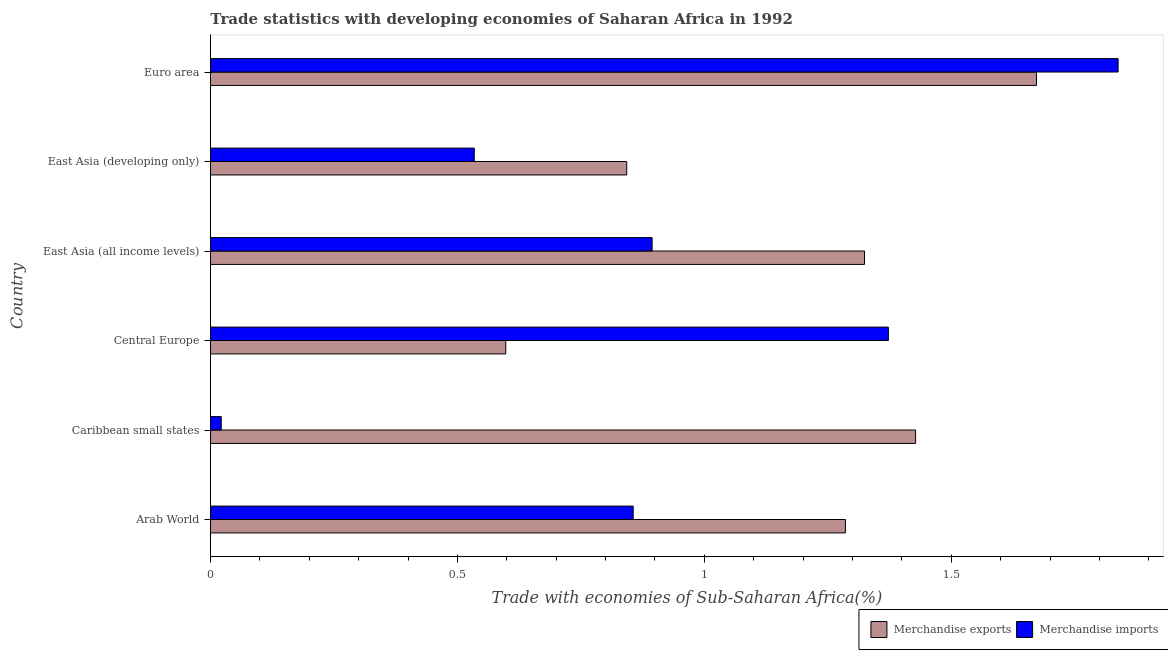How many groups of bars are there?
Offer a very short reply. 6. Are the number of bars per tick equal to the number of legend labels?
Give a very brief answer. Yes. Are the number of bars on each tick of the Y-axis equal?
Your answer should be very brief. Yes. What is the label of the 2nd group of bars from the top?
Keep it short and to the point. East Asia (developing only). What is the merchandise exports in Central Europe?
Provide a succinct answer. 0.6. Across all countries, what is the maximum merchandise imports?
Keep it short and to the point. 1.84. Across all countries, what is the minimum merchandise exports?
Your answer should be very brief. 0.6. In which country was the merchandise imports minimum?
Offer a terse response. Caribbean small states. What is the total merchandise imports in the graph?
Your answer should be very brief. 5.52. What is the difference between the merchandise imports in East Asia (developing only) and that in Euro area?
Provide a short and direct response. -1.3. What is the difference between the merchandise imports in East Asia (all income levels) and the merchandise exports in Arab World?
Provide a succinct answer. -0.39. What is the average merchandise exports per country?
Provide a short and direct response. 1.19. What is the difference between the merchandise exports and merchandise imports in Arab World?
Your response must be concise. 0.43. What is the ratio of the merchandise exports in Arab World to that in Euro area?
Provide a succinct answer. 0.77. Is the merchandise exports in East Asia (developing only) less than that in Euro area?
Ensure brevity in your answer.  Yes. What is the difference between the highest and the second highest merchandise exports?
Make the answer very short. 0.24. What is the difference between the highest and the lowest merchandise exports?
Your answer should be very brief. 1.07. In how many countries, is the merchandise exports greater than the average merchandise exports taken over all countries?
Provide a short and direct response. 4. Is the sum of the merchandise imports in Caribbean small states and Central Europe greater than the maximum merchandise exports across all countries?
Ensure brevity in your answer.  No. How many bars are there?
Provide a succinct answer. 12. Are all the bars in the graph horizontal?
Your response must be concise. Yes. How many countries are there in the graph?
Your response must be concise. 6. What is the difference between two consecutive major ticks on the X-axis?
Your response must be concise. 0.5. Are the values on the major ticks of X-axis written in scientific E-notation?
Give a very brief answer. No. Does the graph contain grids?
Offer a very short reply. No. How are the legend labels stacked?
Ensure brevity in your answer.  Horizontal. What is the title of the graph?
Make the answer very short. Trade statistics with developing economies of Saharan Africa in 1992. What is the label or title of the X-axis?
Provide a short and direct response. Trade with economies of Sub-Saharan Africa(%). What is the label or title of the Y-axis?
Make the answer very short. Country. What is the Trade with economies of Sub-Saharan Africa(%) of Merchandise exports in Arab World?
Your answer should be very brief. 1.29. What is the Trade with economies of Sub-Saharan Africa(%) of Merchandise imports in Arab World?
Your answer should be compact. 0.86. What is the Trade with economies of Sub-Saharan Africa(%) in Merchandise exports in Caribbean small states?
Your answer should be very brief. 1.43. What is the Trade with economies of Sub-Saharan Africa(%) in Merchandise imports in Caribbean small states?
Make the answer very short. 0.02. What is the Trade with economies of Sub-Saharan Africa(%) of Merchandise exports in Central Europe?
Offer a terse response. 0.6. What is the Trade with economies of Sub-Saharan Africa(%) in Merchandise imports in Central Europe?
Offer a terse response. 1.37. What is the Trade with economies of Sub-Saharan Africa(%) of Merchandise exports in East Asia (all income levels)?
Keep it short and to the point. 1.32. What is the Trade with economies of Sub-Saharan Africa(%) of Merchandise imports in East Asia (all income levels)?
Give a very brief answer. 0.89. What is the Trade with economies of Sub-Saharan Africa(%) in Merchandise exports in East Asia (developing only)?
Your answer should be compact. 0.84. What is the Trade with economies of Sub-Saharan Africa(%) of Merchandise imports in East Asia (developing only)?
Make the answer very short. 0.53. What is the Trade with economies of Sub-Saharan Africa(%) in Merchandise exports in Euro area?
Your response must be concise. 1.67. What is the Trade with economies of Sub-Saharan Africa(%) in Merchandise imports in Euro area?
Ensure brevity in your answer.  1.84. Across all countries, what is the maximum Trade with economies of Sub-Saharan Africa(%) of Merchandise exports?
Your answer should be compact. 1.67. Across all countries, what is the maximum Trade with economies of Sub-Saharan Africa(%) in Merchandise imports?
Offer a very short reply. 1.84. Across all countries, what is the minimum Trade with economies of Sub-Saharan Africa(%) in Merchandise exports?
Your response must be concise. 0.6. Across all countries, what is the minimum Trade with economies of Sub-Saharan Africa(%) in Merchandise imports?
Keep it short and to the point. 0.02. What is the total Trade with economies of Sub-Saharan Africa(%) in Merchandise exports in the graph?
Provide a succinct answer. 7.15. What is the total Trade with economies of Sub-Saharan Africa(%) of Merchandise imports in the graph?
Keep it short and to the point. 5.52. What is the difference between the Trade with economies of Sub-Saharan Africa(%) of Merchandise exports in Arab World and that in Caribbean small states?
Ensure brevity in your answer.  -0.14. What is the difference between the Trade with economies of Sub-Saharan Africa(%) of Merchandise imports in Arab World and that in Caribbean small states?
Your answer should be compact. 0.83. What is the difference between the Trade with economies of Sub-Saharan Africa(%) of Merchandise exports in Arab World and that in Central Europe?
Provide a succinct answer. 0.69. What is the difference between the Trade with economies of Sub-Saharan Africa(%) in Merchandise imports in Arab World and that in Central Europe?
Make the answer very short. -0.52. What is the difference between the Trade with economies of Sub-Saharan Africa(%) of Merchandise exports in Arab World and that in East Asia (all income levels)?
Give a very brief answer. -0.04. What is the difference between the Trade with economies of Sub-Saharan Africa(%) in Merchandise imports in Arab World and that in East Asia (all income levels)?
Keep it short and to the point. -0.04. What is the difference between the Trade with economies of Sub-Saharan Africa(%) of Merchandise exports in Arab World and that in East Asia (developing only)?
Make the answer very short. 0.44. What is the difference between the Trade with economies of Sub-Saharan Africa(%) of Merchandise imports in Arab World and that in East Asia (developing only)?
Make the answer very short. 0.32. What is the difference between the Trade with economies of Sub-Saharan Africa(%) of Merchandise exports in Arab World and that in Euro area?
Your answer should be very brief. -0.39. What is the difference between the Trade with economies of Sub-Saharan Africa(%) in Merchandise imports in Arab World and that in Euro area?
Provide a succinct answer. -0.98. What is the difference between the Trade with economies of Sub-Saharan Africa(%) in Merchandise exports in Caribbean small states and that in Central Europe?
Provide a succinct answer. 0.83. What is the difference between the Trade with economies of Sub-Saharan Africa(%) in Merchandise imports in Caribbean small states and that in Central Europe?
Ensure brevity in your answer.  -1.35. What is the difference between the Trade with economies of Sub-Saharan Africa(%) of Merchandise exports in Caribbean small states and that in East Asia (all income levels)?
Ensure brevity in your answer.  0.1. What is the difference between the Trade with economies of Sub-Saharan Africa(%) in Merchandise imports in Caribbean small states and that in East Asia (all income levels)?
Your answer should be very brief. -0.87. What is the difference between the Trade with economies of Sub-Saharan Africa(%) of Merchandise exports in Caribbean small states and that in East Asia (developing only)?
Offer a very short reply. 0.58. What is the difference between the Trade with economies of Sub-Saharan Africa(%) in Merchandise imports in Caribbean small states and that in East Asia (developing only)?
Offer a terse response. -0.51. What is the difference between the Trade with economies of Sub-Saharan Africa(%) in Merchandise exports in Caribbean small states and that in Euro area?
Give a very brief answer. -0.24. What is the difference between the Trade with economies of Sub-Saharan Africa(%) in Merchandise imports in Caribbean small states and that in Euro area?
Ensure brevity in your answer.  -1.82. What is the difference between the Trade with economies of Sub-Saharan Africa(%) of Merchandise exports in Central Europe and that in East Asia (all income levels)?
Keep it short and to the point. -0.73. What is the difference between the Trade with economies of Sub-Saharan Africa(%) of Merchandise imports in Central Europe and that in East Asia (all income levels)?
Ensure brevity in your answer.  0.48. What is the difference between the Trade with economies of Sub-Saharan Africa(%) in Merchandise exports in Central Europe and that in East Asia (developing only)?
Your response must be concise. -0.24. What is the difference between the Trade with economies of Sub-Saharan Africa(%) of Merchandise imports in Central Europe and that in East Asia (developing only)?
Offer a terse response. 0.84. What is the difference between the Trade with economies of Sub-Saharan Africa(%) in Merchandise exports in Central Europe and that in Euro area?
Make the answer very short. -1.07. What is the difference between the Trade with economies of Sub-Saharan Africa(%) of Merchandise imports in Central Europe and that in Euro area?
Your answer should be compact. -0.47. What is the difference between the Trade with economies of Sub-Saharan Africa(%) of Merchandise exports in East Asia (all income levels) and that in East Asia (developing only)?
Offer a terse response. 0.48. What is the difference between the Trade with economies of Sub-Saharan Africa(%) of Merchandise imports in East Asia (all income levels) and that in East Asia (developing only)?
Keep it short and to the point. 0.36. What is the difference between the Trade with economies of Sub-Saharan Africa(%) in Merchandise exports in East Asia (all income levels) and that in Euro area?
Keep it short and to the point. -0.35. What is the difference between the Trade with economies of Sub-Saharan Africa(%) of Merchandise imports in East Asia (all income levels) and that in Euro area?
Make the answer very short. -0.94. What is the difference between the Trade with economies of Sub-Saharan Africa(%) of Merchandise exports in East Asia (developing only) and that in Euro area?
Offer a very short reply. -0.83. What is the difference between the Trade with economies of Sub-Saharan Africa(%) in Merchandise imports in East Asia (developing only) and that in Euro area?
Keep it short and to the point. -1.3. What is the difference between the Trade with economies of Sub-Saharan Africa(%) of Merchandise exports in Arab World and the Trade with economies of Sub-Saharan Africa(%) of Merchandise imports in Caribbean small states?
Provide a short and direct response. 1.26. What is the difference between the Trade with economies of Sub-Saharan Africa(%) of Merchandise exports in Arab World and the Trade with economies of Sub-Saharan Africa(%) of Merchandise imports in Central Europe?
Provide a short and direct response. -0.09. What is the difference between the Trade with economies of Sub-Saharan Africa(%) in Merchandise exports in Arab World and the Trade with economies of Sub-Saharan Africa(%) in Merchandise imports in East Asia (all income levels)?
Give a very brief answer. 0.39. What is the difference between the Trade with economies of Sub-Saharan Africa(%) in Merchandise exports in Arab World and the Trade with economies of Sub-Saharan Africa(%) in Merchandise imports in East Asia (developing only)?
Your response must be concise. 0.75. What is the difference between the Trade with economies of Sub-Saharan Africa(%) of Merchandise exports in Arab World and the Trade with economies of Sub-Saharan Africa(%) of Merchandise imports in Euro area?
Your answer should be very brief. -0.55. What is the difference between the Trade with economies of Sub-Saharan Africa(%) in Merchandise exports in Caribbean small states and the Trade with economies of Sub-Saharan Africa(%) in Merchandise imports in Central Europe?
Offer a terse response. 0.06. What is the difference between the Trade with economies of Sub-Saharan Africa(%) in Merchandise exports in Caribbean small states and the Trade with economies of Sub-Saharan Africa(%) in Merchandise imports in East Asia (all income levels)?
Your answer should be compact. 0.53. What is the difference between the Trade with economies of Sub-Saharan Africa(%) in Merchandise exports in Caribbean small states and the Trade with economies of Sub-Saharan Africa(%) in Merchandise imports in East Asia (developing only)?
Your answer should be very brief. 0.89. What is the difference between the Trade with economies of Sub-Saharan Africa(%) in Merchandise exports in Caribbean small states and the Trade with economies of Sub-Saharan Africa(%) in Merchandise imports in Euro area?
Ensure brevity in your answer.  -0.41. What is the difference between the Trade with economies of Sub-Saharan Africa(%) of Merchandise exports in Central Europe and the Trade with economies of Sub-Saharan Africa(%) of Merchandise imports in East Asia (all income levels)?
Ensure brevity in your answer.  -0.3. What is the difference between the Trade with economies of Sub-Saharan Africa(%) in Merchandise exports in Central Europe and the Trade with economies of Sub-Saharan Africa(%) in Merchandise imports in East Asia (developing only)?
Your response must be concise. 0.06. What is the difference between the Trade with economies of Sub-Saharan Africa(%) in Merchandise exports in Central Europe and the Trade with economies of Sub-Saharan Africa(%) in Merchandise imports in Euro area?
Keep it short and to the point. -1.24. What is the difference between the Trade with economies of Sub-Saharan Africa(%) in Merchandise exports in East Asia (all income levels) and the Trade with economies of Sub-Saharan Africa(%) in Merchandise imports in East Asia (developing only)?
Offer a terse response. 0.79. What is the difference between the Trade with economies of Sub-Saharan Africa(%) in Merchandise exports in East Asia (all income levels) and the Trade with economies of Sub-Saharan Africa(%) in Merchandise imports in Euro area?
Your answer should be very brief. -0.51. What is the difference between the Trade with economies of Sub-Saharan Africa(%) of Merchandise exports in East Asia (developing only) and the Trade with economies of Sub-Saharan Africa(%) of Merchandise imports in Euro area?
Make the answer very short. -1. What is the average Trade with economies of Sub-Saharan Africa(%) in Merchandise exports per country?
Your answer should be very brief. 1.19. What is the average Trade with economies of Sub-Saharan Africa(%) in Merchandise imports per country?
Offer a very short reply. 0.92. What is the difference between the Trade with economies of Sub-Saharan Africa(%) of Merchandise exports and Trade with economies of Sub-Saharan Africa(%) of Merchandise imports in Arab World?
Provide a succinct answer. 0.43. What is the difference between the Trade with economies of Sub-Saharan Africa(%) in Merchandise exports and Trade with economies of Sub-Saharan Africa(%) in Merchandise imports in Caribbean small states?
Make the answer very short. 1.41. What is the difference between the Trade with economies of Sub-Saharan Africa(%) in Merchandise exports and Trade with economies of Sub-Saharan Africa(%) in Merchandise imports in Central Europe?
Make the answer very short. -0.77. What is the difference between the Trade with economies of Sub-Saharan Africa(%) of Merchandise exports and Trade with economies of Sub-Saharan Africa(%) of Merchandise imports in East Asia (all income levels)?
Your answer should be compact. 0.43. What is the difference between the Trade with economies of Sub-Saharan Africa(%) of Merchandise exports and Trade with economies of Sub-Saharan Africa(%) of Merchandise imports in East Asia (developing only)?
Provide a succinct answer. 0.31. What is the difference between the Trade with economies of Sub-Saharan Africa(%) in Merchandise exports and Trade with economies of Sub-Saharan Africa(%) in Merchandise imports in Euro area?
Provide a short and direct response. -0.17. What is the ratio of the Trade with economies of Sub-Saharan Africa(%) of Merchandise exports in Arab World to that in Caribbean small states?
Offer a terse response. 0.9. What is the ratio of the Trade with economies of Sub-Saharan Africa(%) of Merchandise imports in Arab World to that in Caribbean small states?
Your response must be concise. 39.28. What is the ratio of the Trade with economies of Sub-Saharan Africa(%) of Merchandise exports in Arab World to that in Central Europe?
Your answer should be compact. 2.15. What is the ratio of the Trade with economies of Sub-Saharan Africa(%) in Merchandise imports in Arab World to that in Central Europe?
Make the answer very short. 0.62. What is the ratio of the Trade with economies of Sub-Saharan Africa(%) in Merchandise exports in Arab World to that in East Asia (all income levels)?
Provide a short and direct response. 0.97. What is the ratio of the Trade with economies of Sub-Saharan Africa(%) in Merchandise imports in Arab World to that in East Asia (all income levels)?
Provide a short and direct response. 0.96. What is the ratio of the Trade with economies of Sub-Saharan Africa(%) in Merchandise exports in Arab World to that in East Asia (developing only)?
Your answer should be very brief. 1.53. What is the ratio of the Trade with economies of Sub-Saharan Africa(%) in Merchandise imports in Arab World to that in East Asia (developing only)?
Your response must be concise. 1.6. What is the ratio of the Trade with economies of Sub-Saharan Africa(%) in Merchandise exports in Arab World to that in Euro area?
Your answer should be compact. 0.77. What is the ratio of the Trade with economies of Sub-Saharan Africa(%) in Merchandise imports in Arab World to that in Euro area?
Provide a succinct answer. 0.47. What is the ratio of the Trade with economies of Sub-Saharan Africa(%) in Merchandise exports in Caribbean small states to that in Central Europe?
Ensure brevity in your answer.  2.39. What is the ratio of the Trade with economies of Sub-Saharan Africa(%) of Merchandise imports in Caribbean small states to that in Central Europe?
Your answer should be compact. 0.02. What is the ratio of the Trade with economies of Sub-Saharan Africa(%) of Merchandise exports in Caribbean small states to that in East Asia (all income levels)?
Make the answer very short. 1.08. What is the ratio of the Trade with economies of Sub-Saharan Africa(%) of Merchandise imports in Caribbean small states to that in East Asia (all income levels)?
Your answer should be compact. 0.02. What is the ratio of the Trade with economies of Sub-Saharan Africa(%) in Merchandise exports in Caribbean small states to that in East Asia (developing only)?
Provide a short and direct response. 1.69. What is the ratio of the Trade with economies of Sub-Saharan Africa(%) in Merchandise imports in Caribbean small states to that in East Asia (developing only)?
Your answer should be very brief. 0.04. What is the ratio of the Trade with economies of Sub-Saharan Africa(%) of Merchandise exports in Caribbean small states to that in Euro area?
Offer a terse response. 0.85. What is the ratio of the Trade with economies of Sub-Saharan Africa(%) of Merchandise imports in Caribbean small states to that in Euro area?
Offer a terse response. 0.01. What is the ratio of the Trade with economies of Sub-Saharan Africa(%) in Merchandise exports in Central Europe to that in East Asia (all income levels)?
Provide a short and direct response. 0.45. What is the ratio of the Trade with economies of Sub-Saharan Africa(%) in Merchandise imports in Central Europe to that in East Asia (all income levels)?
Ensure brevity in your answer.  1.53. What is the ratio of the Trade with economies of Sub-Saharan Africa(%) in Merchandise exports in Central Europe to that in East Asia (developing only)?
Offer a very short reply. 0.71. What is the ratio of the Trade with economies of Sub-Saharan Africa(%) in Merchandise imports in Central Europe to that in East Asia (developing only)?
Provide a succinct answer. 2.57. What is the ratio of the Trade with economies of Sub-Saharan Africa(%) in Merchandise exports in Central Europe to that in Euro area?
Offer a terse response. 0.36. What is the ratio of the Trade with economies of Sub-Saharan Africa(%) of Merchandise imports in Central Europe to that in Euro area?
Provide a short and direct response. 0.75. What is the ratio of the Trade with economies of Sub-Saharan Africa(%) of Merchandise exports in East Asia (all income levels) to that in East Asia (developing only)?
Your answer should be very brief. 1.57. What is the ratio of the Trade with economies of Sub-Saharan Africa(%) in Merchandise imports in East Asia (all income levels) to that in East Asia (developing only)?
Keep it short and to the point. 1.67. What is the ratio of the Trade with economies of Sub-Saharan Africa(%) in Merchandise exports in East Asia (all income levels) to that in Euro area?
Offer a very short reply. 0.79. What is the ratio of the Trade with economies of Sub-Saharan Africa(%) of Merchandise imports in East Asia (all income levels) to that in Euro area?
Offer a terse response. 0.49. What is the ratio of the Trade with economies of Sub-Saharan Africa(%) of Merchandise exports in East Asia (developing only) to that in Euro area?
Give a very brief answer. 0.5. What is the ratio of the Trade with economies of Sub-Saharan Africa(%) of Merchandise imports in East Asia (developing only) to that in Euro area?
Give a very brief answer. 0.29. What is the difference between the highest and the second highest Trade with economies of Sub-Saharan Africa(%) in Merchandise exports?
Offer a terse response. 0.24. What is the difference between the highest and the second highest Trade with economies of Sub-Saharan Africa(%) in Merchandise imports?
Offer a very short reply. 0.47. What is the difference between the highest and the lowest Trade with economies of Sub-Saharan Africa(%) of Merchandise exports?
Make the answer very short. 1.07. What is the difference between the highest and the lowest Trade with economies of Sub-Saharan Africa(%) of Merchandise imports?
Keep it short and to the point. 1.82. 